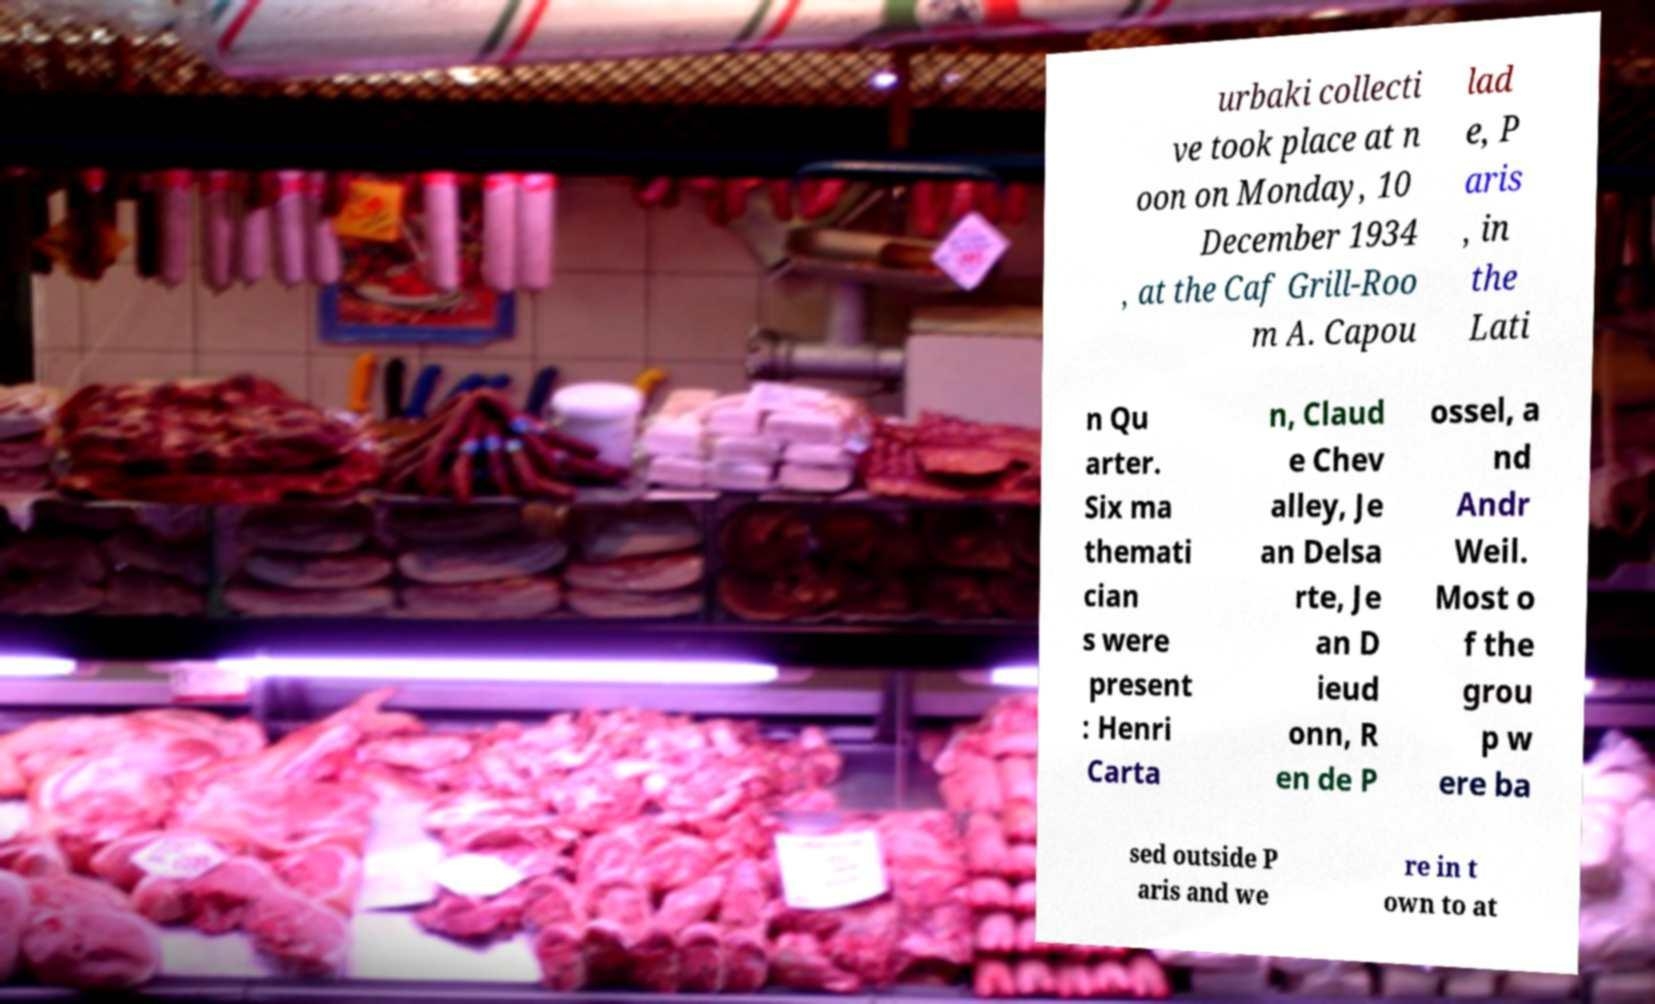I need the written content from this picture converted into text. Can you do that? urbaki collecti ve took place at n oon on Monday, 10 December 1934 , at the Caf Grill-Roo m A. Capou lad e, P aris , in the Lati n Qu arter. Six ma themati cian s were present : Henri Carta n, Claud e Chev alley, Je an Delsa rte, Je an D ieud onn, R en de P ossel, a nd Andr Weil. Most o f the grou p w ere ba sed outside P aris and we re in t own to at 